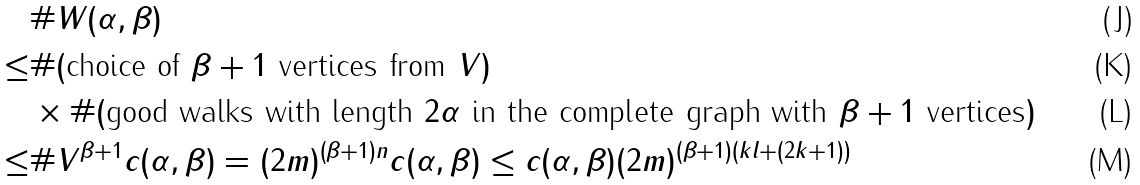Convert formula to latex. <formula><loc_0><loc_0><loc_500><loc_500>& \# W ( \alpha , \beta ) \\ \leq & \# ( \text {choice of } \beta + 1 \text { vertices from } V ) \\ & \times \# ( \text {good walks with length } 2 \alpha \text { in the complete graph with } \beta + 1 \text { vertices} ) \\ \leq & \# V ^ { \beta + 1 } c ( \alpha , \beta ) = ( 2 m ) ^ { ( \beta + 1 ) n } c ( \alpha , \beta ) \leq c ( \alpha , \beta ) ( 2 m ) ^ { ( \beta + 1 ) ( k l + ( 2 k + 1 ) ) }</formula> 